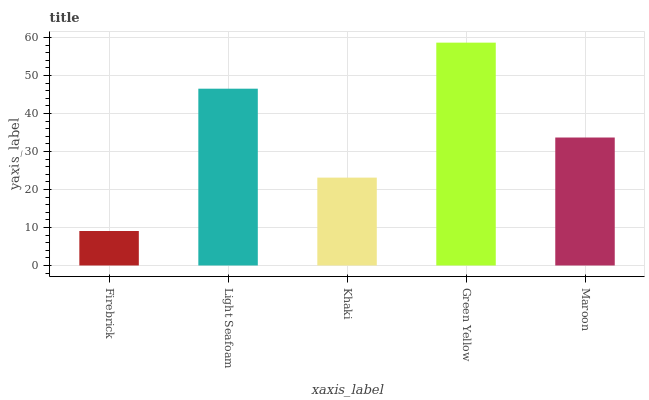Is Firebrick the minimum?
Answer yes or no. Yes. Is Green Yellow the maximum?
Answer yes or no. Yes. Is Light Seafoam the minimum?
Answer yes or no. No. Is Light Seafoam the maximum?
Answer yes or no. No. Is Light Seafoam greater than Firebrick?
Answer yes or no. Yes. Is Firebrick less than Light Seafoam?
Answer yes or no. Yes. Is Firebrick greater than Light Seafoam?
Answer yes or no. No. Is Light Seafoam less than Firebrick?
Answer yes or no. No. Is Maroon the high median?
Answer yes or no. Yes. Is Maroon the low median?
Answer yes or no. Yes. Is Green Yellow the high median?
Answer yes or no. No. Is Green Yellow the low median?
Answer yes or no. No. 